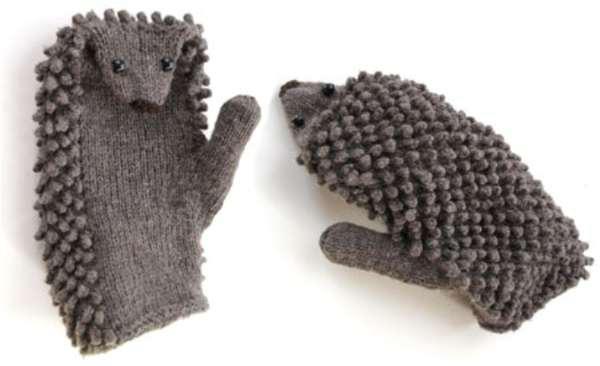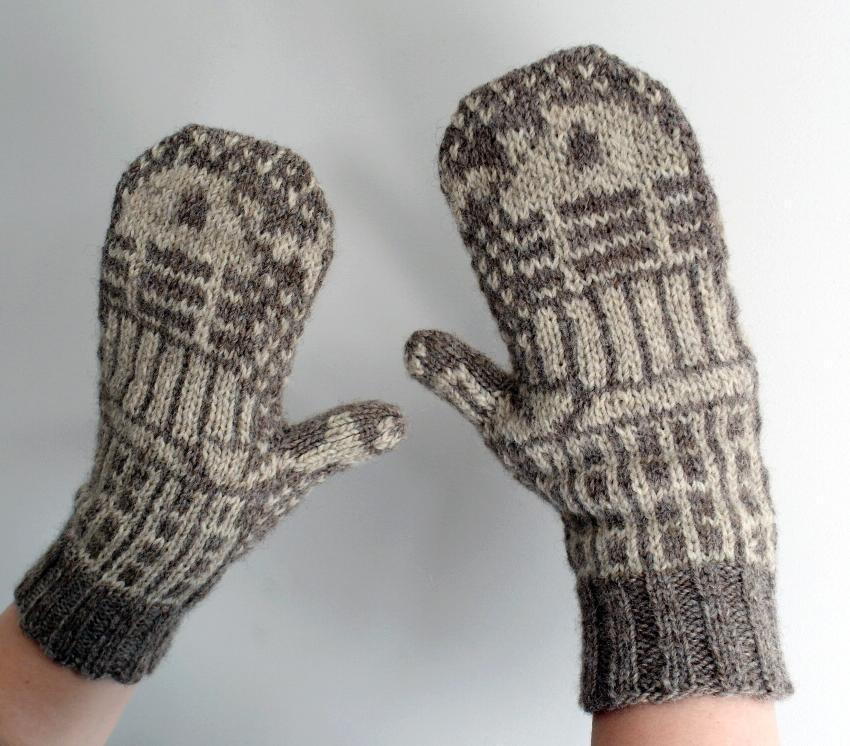The first image is the image on the left, the second image is the image on the right. Evaluate the accuracy of this statement regarding the images: "One pair of mittons has a visible animal design knitted in, and the other pair does not.". Is it true? Answer yes or no. Yes. The first image is the image on the left, the second image is the image on the right. For the images shown, is this caption "A pair of gloves is worn by a human." true? Answer yes or no. Yes. 